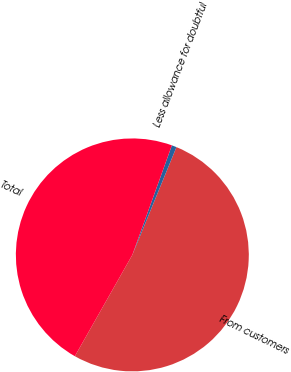Convert chart to OTSL. <chart><loc_0><loc_0><loc_500><loc_500><pie_chart><fcel>From customers<fcel>Less allowance for doubtful<fcel>Total<nl><fcel>52.03%<fcel>0.67%<fcel>47.3%<nl></chart> 